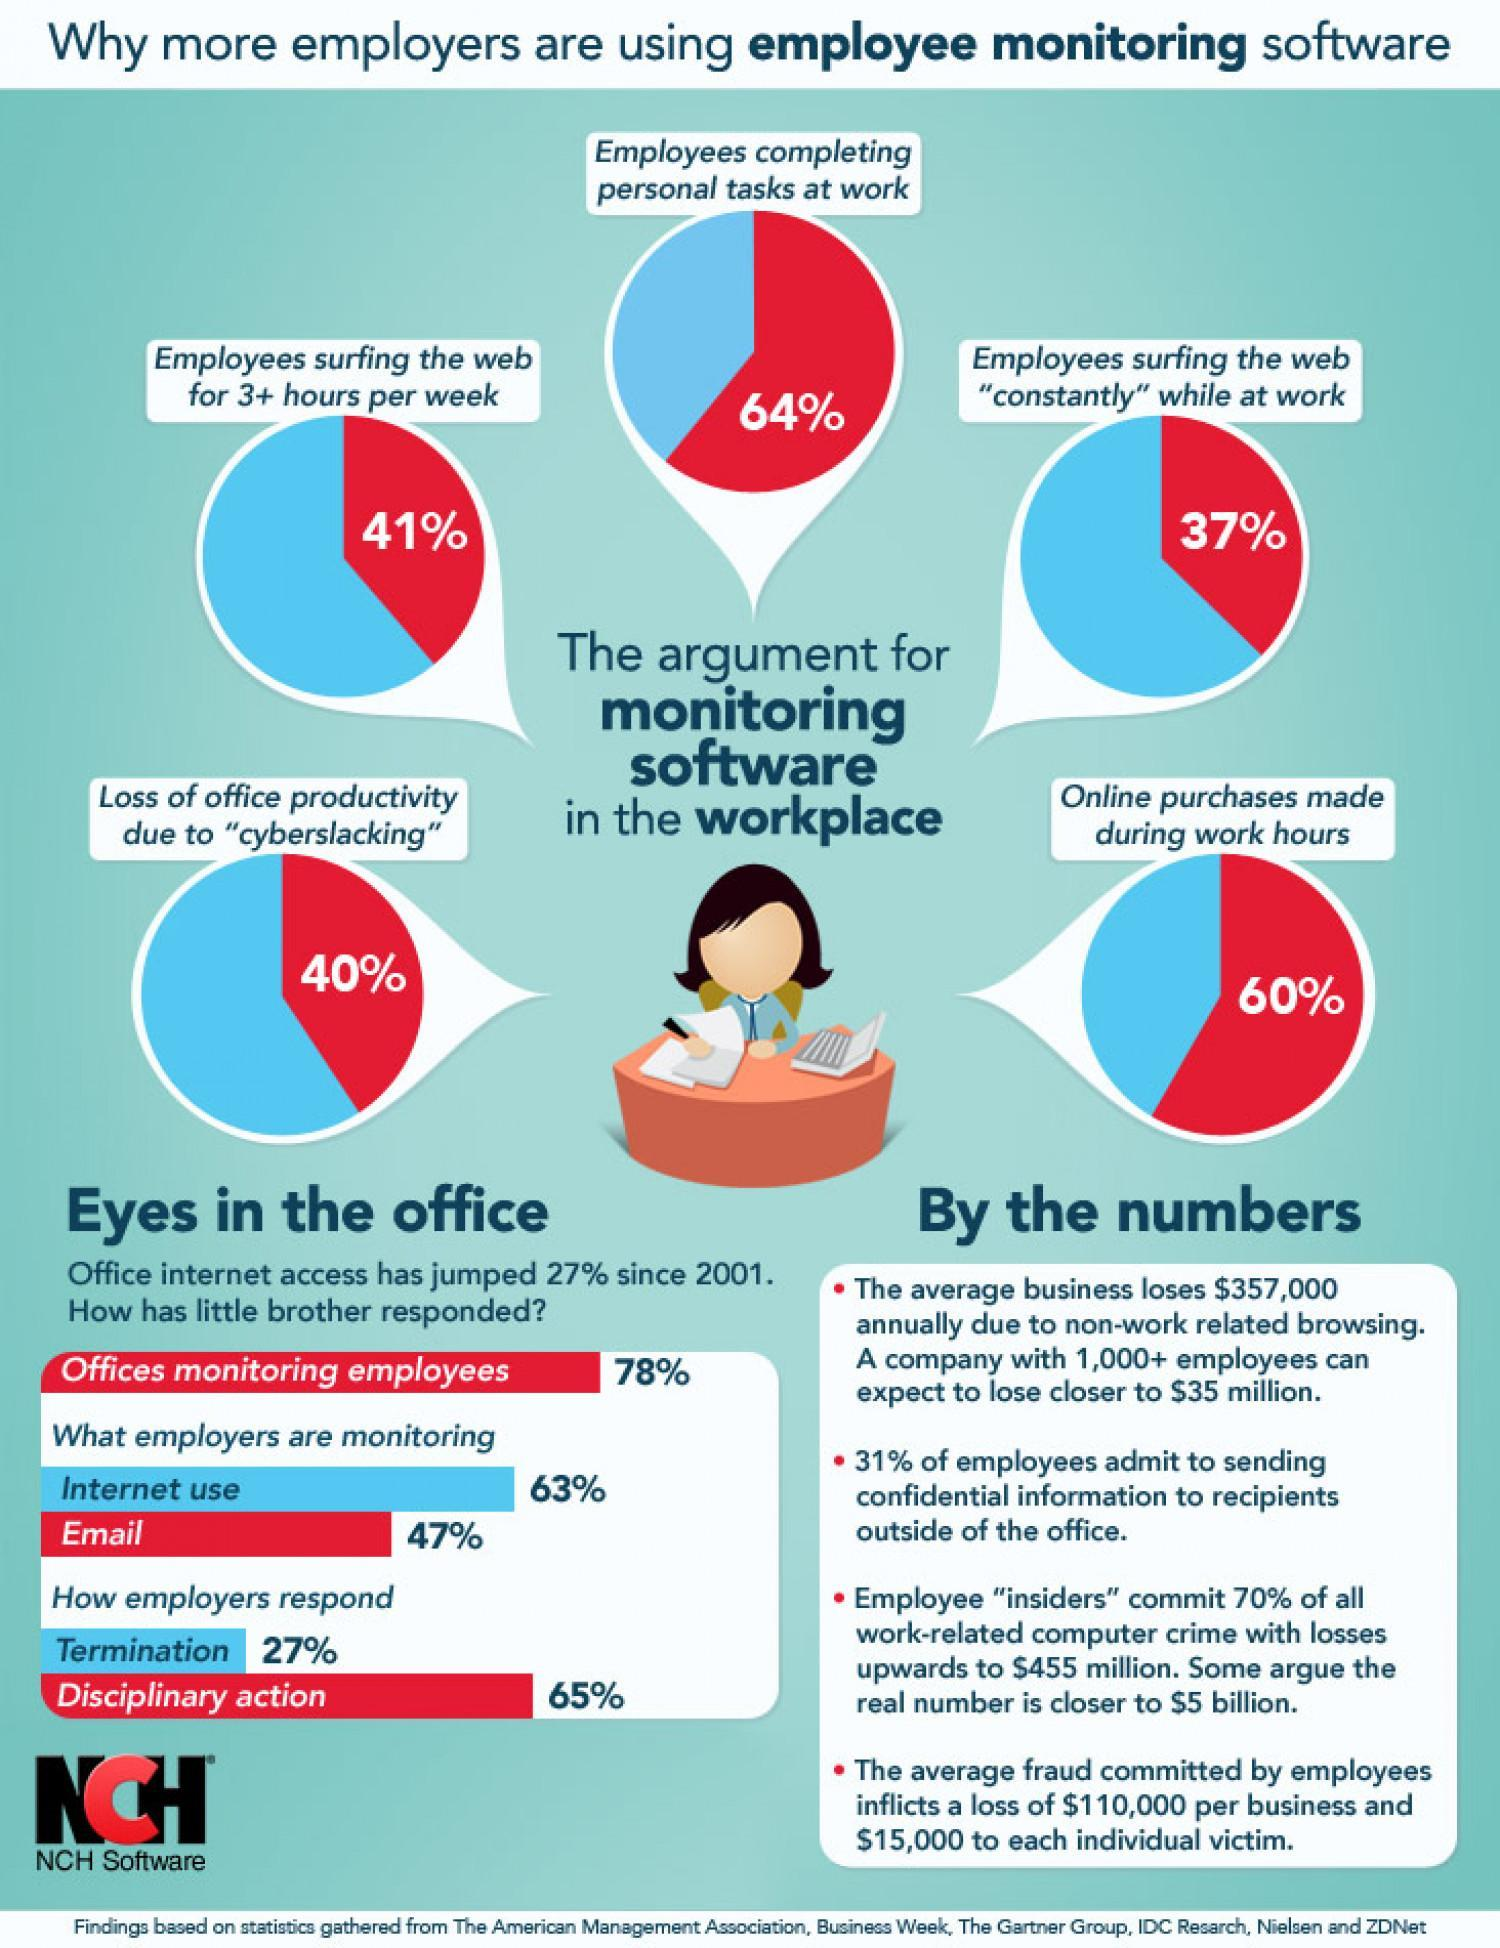What percent of employees do not make online purchases during work hours?
Answer the question with a short phrase. 40% Which method is adopted by most employers if they find about internet use during work hours? Disciplinary action 